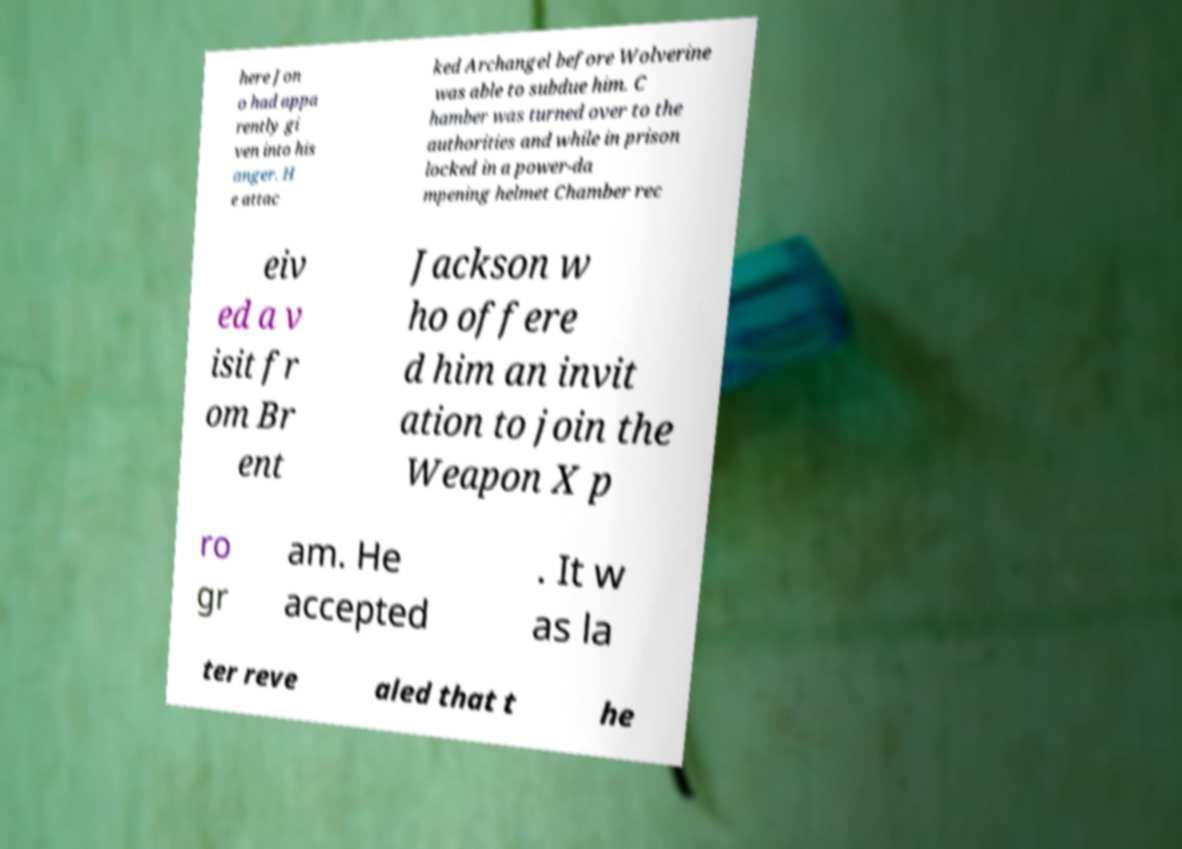Could you assist in decoding the text presented in this image and type it out clearly? here Jon o had appa rently gi ven into his anger. H e attac ked Archangel before Wolverine was able to subdue him. C hamber was turned over to the authorities and while in prison locked in a power-da mpening helmet Chamber rec eiv ed a v isit fr om Br ent Jackson w ho offere d him an invit ation to join the Weapon X p ro gr am. He accepted . It w as la ter reve aled that t he 